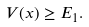Convert formula to latex. <formula><loc_0><loc_0><loc_500><loc_500>V ( x ) \geq E _ { 1 } .</formula> 